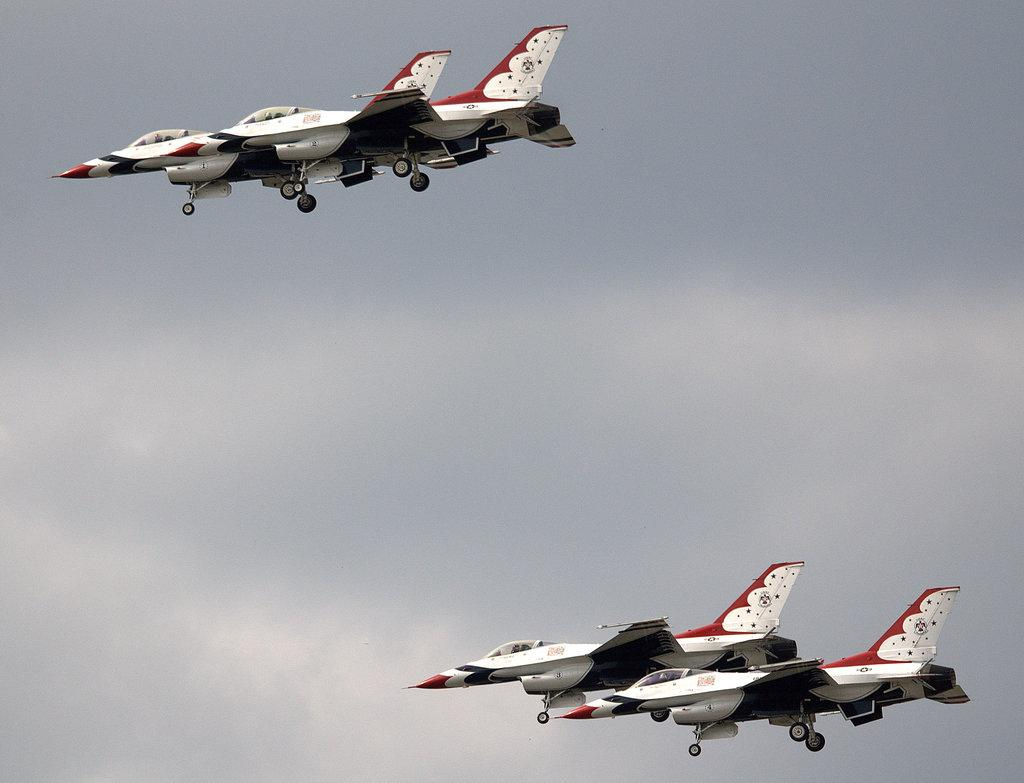What is the main subject of the image? The main subject of the image is aeroplanes. Where are the aeroplanes located in the image? The aeroplanes are flying in the sky. In which direction are the aeroplanes flying? The aeroplanes are flying towards the left. Can you see any fairies flying alongside the aeroplanes in the image? There are no fairies present in the image; it only features aeroplanes flying in the sky. Is there a library visible in the image? There is no library present in the image; it only features aeroplanes flying in the sky. 